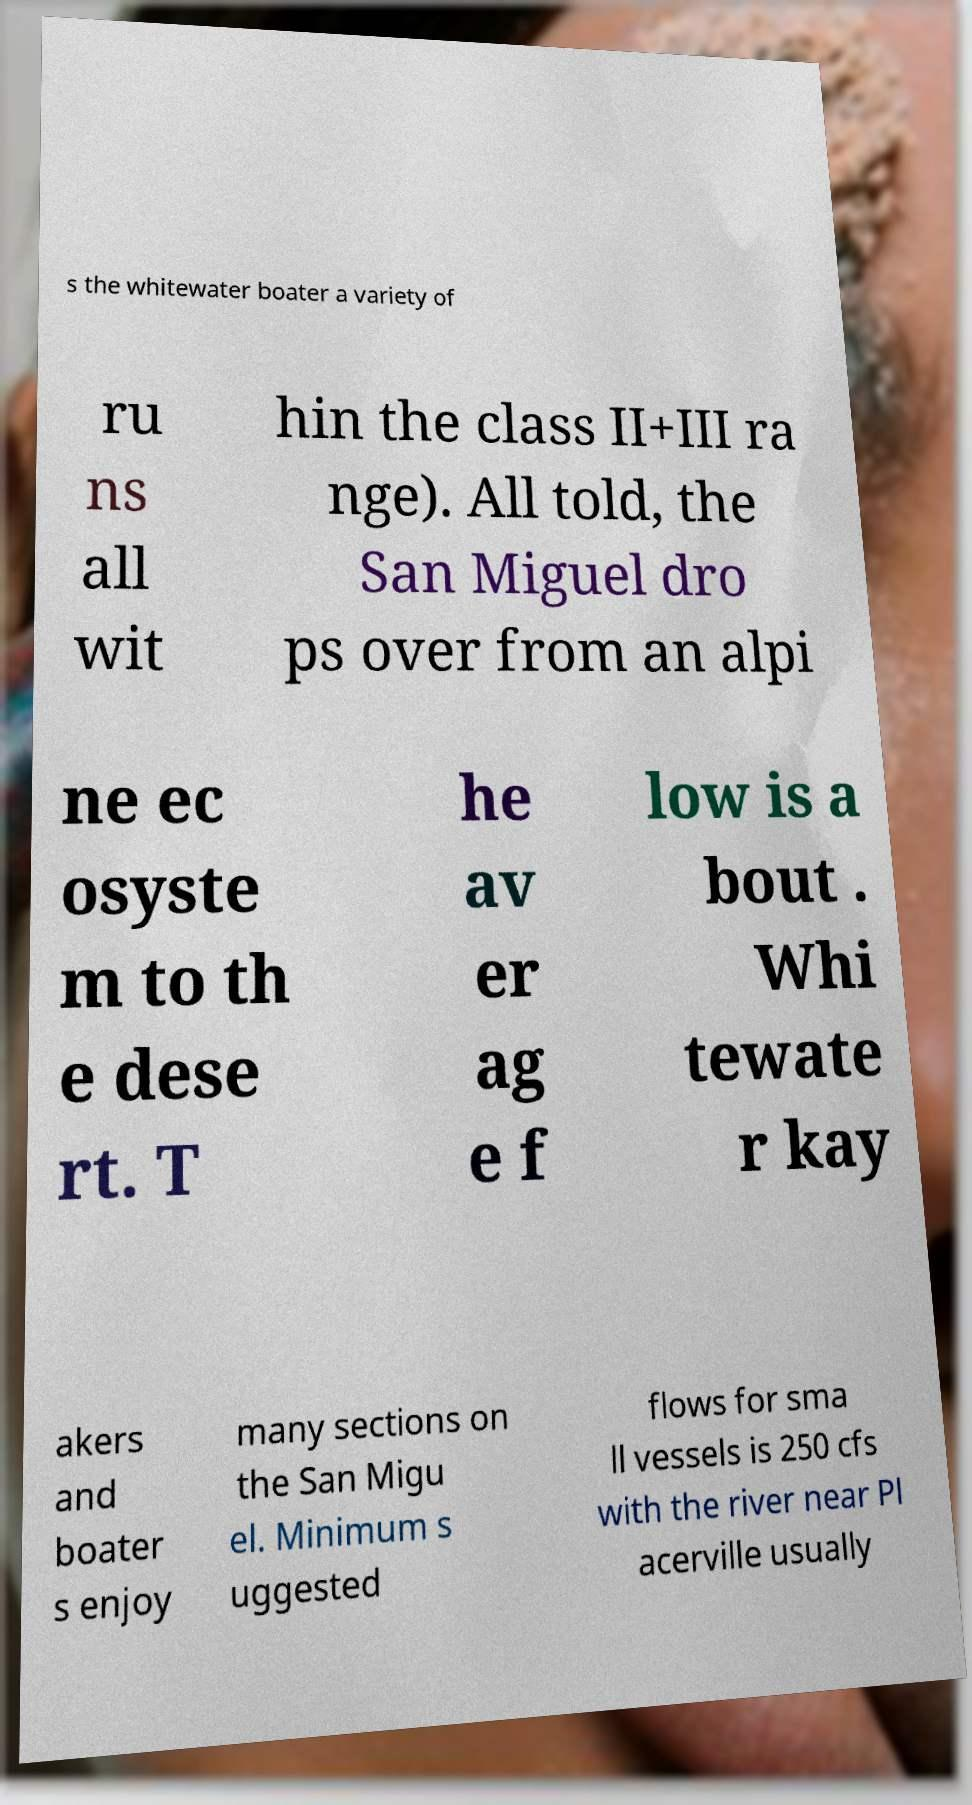Could you assist in decoding the text presented in this image and type it out clearly? s the whitewater boater a variety of ru ns all wit hin the class II+III ra nge). All told, the San Miguel dro ps over from an alpi ne ec osyste m to th e dese rt. T he av er ag e f low is a bout . Whi tewate r kay akers and boater s enjoy many sections on the San Migu el. Minimum s uggested flows for sma ll vessels is 250 cfs with the river near Pl acerville usually 